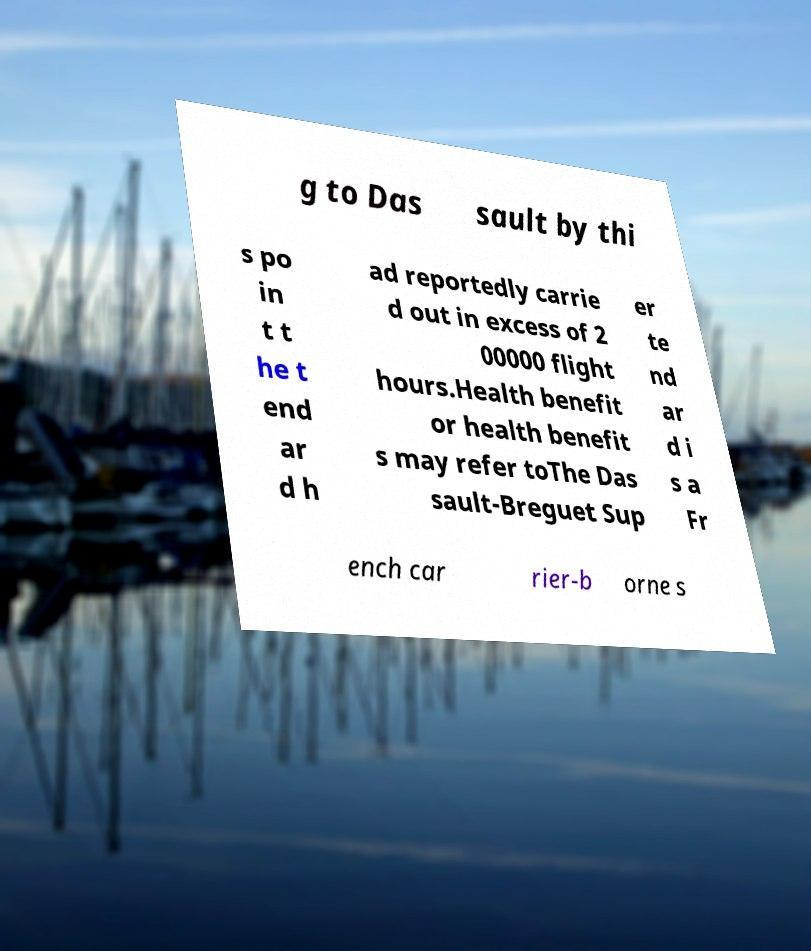For documentation purposes, I need the text within this image transcribed. Could you provide that? g to Das sault by thi s po in t t he t end ar d h ad reportedly carrie d out in excess of 2 00000 flight hours.Health benefit or health benefit s may refer toThe Das sault-Breguet Sup er te nd ar d i s a Fr ench car rier-b orne s 